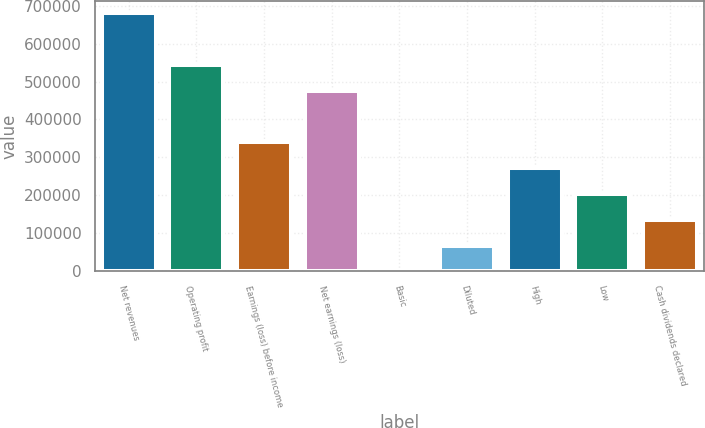<chart> <loc_0><loc_0><loc_500><loc_500><bar_chart><fcel>Net revenues<fcel>Operating profit<fcel>Earnings (loss) before income<fcel>Net earnings (loss)<fcel>Basic<fcel>Diluted<fcel>High<fcel>Low<fcel>Cash dividends declared<nl><fcel>679453<fcel>543562<fcel>339727<fcel>475617<fcel>0.24<fcel>67945.5<fcel>271781<fcel>203836<fcel>135891<nl></chart> 